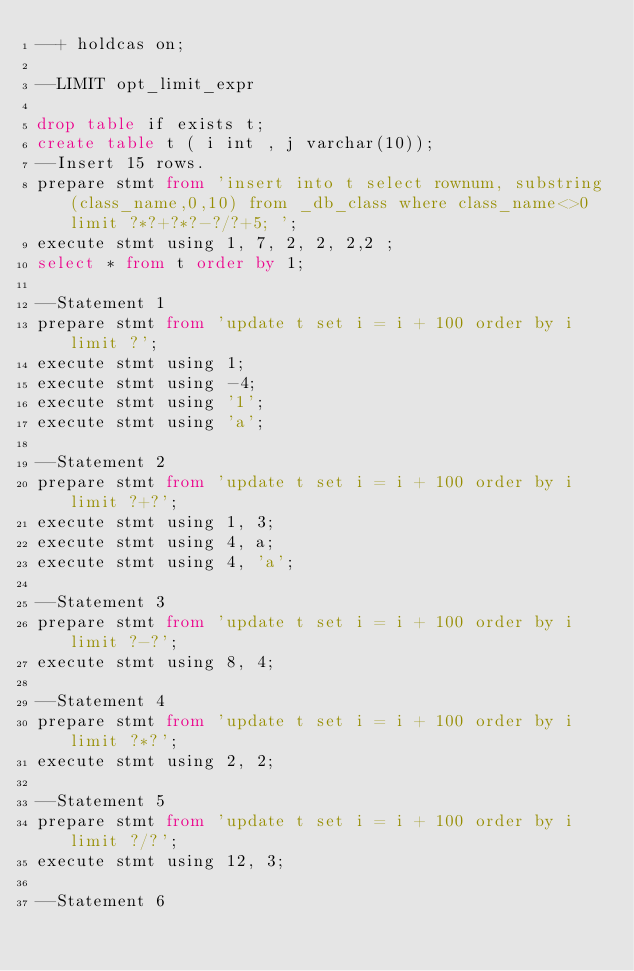Convert code to text. <code><loc_0><loc_0><loc_500><loc_500><_SQL_>--+ holdcas on;

--LIMIT opt_limit_expr 

drop table if exists t;
create table t ( i int , j varchar(10));
--Insert 15 rows. 
prepare stmt from 'insert into t select rownum, substring(class_name,0,10) from _db_class where class_name<>0 limit ?*?+?*?-?/?+5; ';
execute stmt using 1, 7, 2, 2, 2,2 ;
select * from t order by 1;

--Statement 1
prepare stmt from 'update t set i = i + 100 order by i limit ?';
execute stmt using 1;
execute stmt using -4;
execute stmt using '1';
execute stmt using 'a';

--Statement 2
prepare stmt from 'update t set i = i + 100 order by i limit ?+?';
execute stmt using 1, 3;
execute stmt using 4, a;
execute stmt using 4, 'a';

--Statement 3
prepare stmt from 'update t set i = i + 100 order by i limit ?-?';
execute stmt using 8, 4;

--Statement 4
prepare stmt from 'update t set i = i + 100 order by i limit ?*?';
execute stmt using 2, 2;

--Statement 5
prepare stmt from 'update t set i = i + 100 order by i limit ?/?';
execute stmt using 12, 3;

--Statement 6</code> 